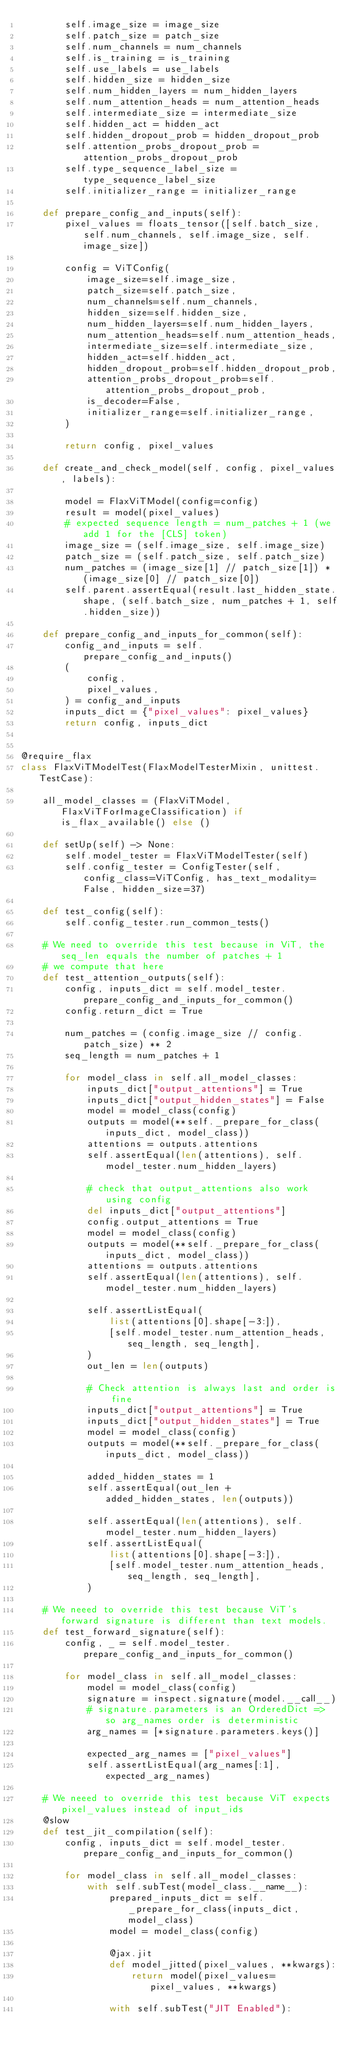<code> <loc_0><loc_0><loc_500><loc_500><_Python_>        self.image_size = image_size
        self.patch_size = patch_size
        self.num_channels = num_channels
        self.is_training = is_training
        self.use_labels = use_labels
        self.hidden_size = hidden_size
        self.num_hidden_layers = num_hidden_layers
        self.num_attention_heads = num_attention_heads
        self.intermediate_size = intermediate_size
        self.hidden_act = hidden_act
        self.hidden_dropout_prob = hidden_dropout_prob
        self.attention_probs_dropout_prob = attention_probs_dropout_prob
        self.type_sequence_label_size = type_sequence_label_size
        self.initializer_range = initializer_range

    def prepare_config_and_inputs(self):
        pixel_values = floats_tensor([self.batch_size, self.num_channels, self.image_size, self.image_size])

        config = ViTConfig(
            image_size=self.image_size,
            patch_size=self.patch_size,
            num_channels=self.num_channels,
            hidden_size=self.hidden_size,
            num_hidden_layers=self.num_hidden_layers,
            num_attention_heads=self.num_attention_heads,
            intermediate_size=self.intermediate_size,
            hidden_act=self.hidden_act,
            hidden_dropout_prob=self.hidden_dropout_prob,
            attention_probs_dropout_prob=self.attention_probs_dropout_prob,
            is_decoder=False,
            initializer_range=self.initializer_range,
        )

        return config, pixel_values

    def create_and_check_model(self, config, pixel_values, labels):

        model = FlaxViTModel(config=config)
        result = model(pixel_values)
        # expected sequence length = num_patches + 1 (we add 1 for the [CLS] token)
        image_size = (self.image_size, self.image_size)
        patch_size = (self.patch_size, self.patch_size)
        num_patches = (image_size[1] // patch_size[1]) * (image_size[0] // patch_size[0])
        self.parent.assertEqual(result.last_hidden_state.shape, (self.batch_size, num_patches + 1, self.hidden_size))

    def prepare_config_and_inputs_for_common(self):
        config_and_inputs = self.prepare_config_and_inputs()
        (
            config,
            pixel_values,
        ) = config_and_inputs
        inputs_dict = {"pixel_values": pixel_values}
        return config, inputs_dict


@require_flax
class FlaxViTModelTest(FlaxModelTesterMixin, unittest.TestCase):

    all_model_classes = (FlaxViTModel, FlaxViTForImageClassification) if is_flax_available() else ()

    def setUp(self) -> None:
        self.model_tester = FlaxViTModelTester(self)
        self.config_tester = ConfigTester(self, config_class=ViTConfig, has_text_modality=False, hidden_size=37)

    def test_config(self):
        self.config_tester.run_common_tests()

    # We need to override this test because in ViT, the seq_len equals the number of patches + 1
    # we compute that here
    def test_attention_outputs(self):
        config, inputs_dict = self.model_tester.prepare_config_and_inputs_for_common()
        config.return_dict = True

        num_patches = (config.image_size // config.patch_size) ** 2
        seq_length = num_patches + 1

        for model_class in self.all_model_classes:
            inputs_dict["output_attentions"] = True
            inputs_dict["output_hidden_states"] = False
            model = model_class(config)
            outputs = model(**self._prepare_for_class(inputs_dict, model_class))
            attentions = outputs.attentions
            self.assertEqual(len(attentions), self.model_tester.num_hidden_layers)

            # check that output_attentions also work using config
            del inputs_dict["output_attentions"]
            config.output_attentions = True
            model = model_class(config)
            outputs = model(**self._prepare_for_class(inputs_dict, model_class))
            attentions = outputs.attentions
            self.assertEqual(len(attentions), self.model_tester.num_hidden_layers)

            self.assertListEqual(
                list(attentions[0].shape[-3:]),
                [self.model_tester.num_attention_heads, seq_length, seq_length],
            )
            out_len = len(outputs)

            # Check attention is always last and order is fine
            inputs_dict["output_attentions"] = True
            inputs_dict["output_hidden_states"] = True
            model = model_class(config)
            outputs = model(**self._prepare_for_class(inputs_dict, model_class))

            added_hidden_states = 1
            self.assertEqual(out_len + added_hidden_states, len(outputs))

            self.assertEqual(len(attentions), self.model_tester.num_hidden_layers)
            self.assertListEqual(
                list(attentions[0].shape[-3:]),
                [self.model_tester.num_attention_heads, seq_length, seq_length],
            )

    # We neeed to override this test because ViT's forward signature is different than text models.
    def test_forward_signature(self):
        config, _ = self.model_tester.prepare_config_and_inputs_for_common()

        for model_class in self.all_model_classes:
            model = model_class(config)
            signature = inspect.signature(model.__call__)
            # signature.parameters is an OrderedDict => so arg_names order is deterministic
            arg_names = [*signature.parameters.keys()]

            expected_arg_names = ["pixel_values"]
            self.assertListEqual(arg_names[:1], expected_arg_names)

    # We neeed to override this test because ViT expects pixel_values instead of input_ids
    @slow
    def test_jit_compilation(self):
        config, inputs_dict = self.model_tester.prepare_config_and_inputs_for_common()

        for model_class in self.all_model_classes:
            with self.subTest(model_class.__name__):
                prepared_inputs_dict = self._prepare_for_class(inputs_dict, model_class)
                model = model_class(config)

                @jax.jit
                def model_jitted(pixel_values, **kwargs):
                    return model(pixel_values=pixel_values, **kwargs)

                with self.subTest("JIT Enabled"):</code> 